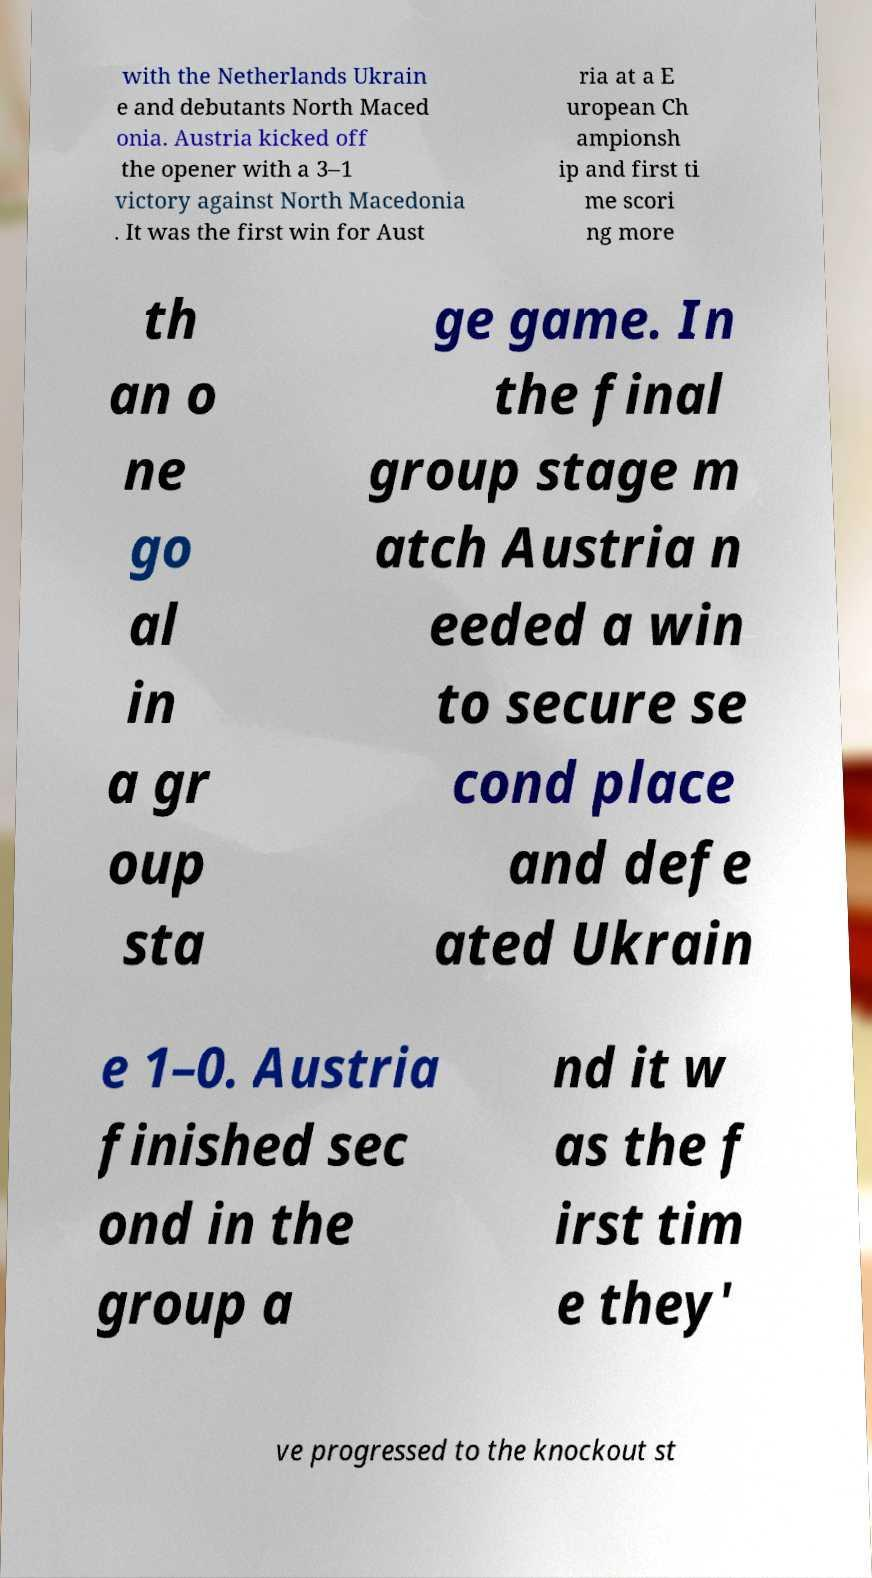What messages or text are displayed in this image? I need them in a readable, typed format. with the Netherlands Ukrain e and debutants North Maced onia. Austria kicked off the opener with a 3–1 victory against North Macedonia . It was the first win for Aust ria at a E uropean Ch ampionsh ip and first ti me scori ng more th an o ne go al in a gr oup sta ge game. In the final group stage m atch Austria n eeded a win to secure se cond place and defe ated Ukrain e 1–0. Austria finished sec ond in the group a nd it w as the f irst tim e they' ve progressed to the knockout st 